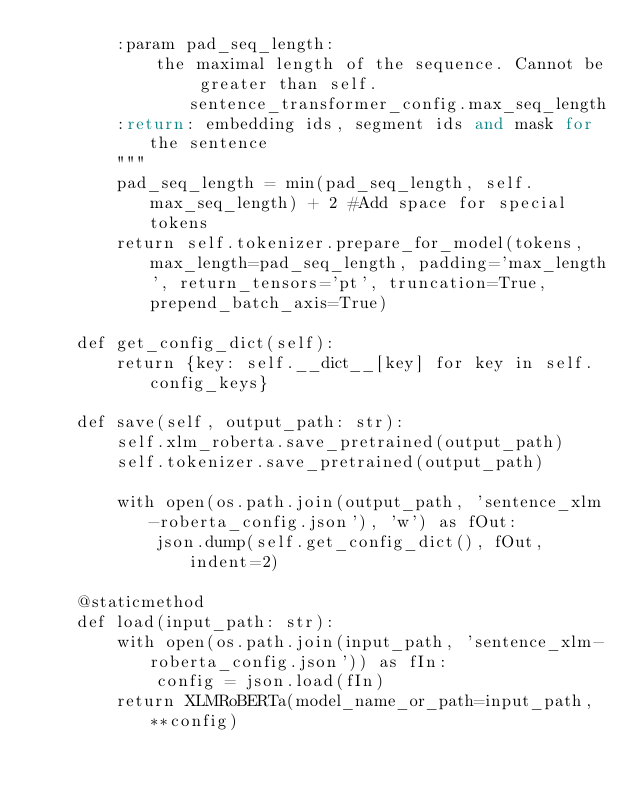<code> <loc_0><loc_0><loc_500><loc_500><_Python_>        :param pad_seq_length:
            the maximal length of the sequence. Cannot be greater than self.sentence_transformer_config.max_seq_length
        :return: embedding ids, segment ids and mask for the sentence
        """
        pad_seq_length = min(pad_seq_length, self.max_seq_length) + 2 #Add space for special tokens
        return self.tokenizer.prepare_for_model(tokens, max_length=pad_seq_length, padding='max_length', return_tensors='pt', truncation=True, prepend_batch_axis=True)

    def get_config_dict(self):
        return {key: self.__dict__[key] for key in self.config_keys}

    def save(self, output_path: str):
        self.xlm_roberta.save_pretrained(output_path)
        self.tokenizer.save_pretrained(output_path)

        with open(os.path.join(output_path, 'sentence_xlm-roberta_config.json'), 'w') as fOut:
            json.dump(self.get_config_dict(), fOut, indent=2)

    @staticmethod
    def load(input_path: str):
        with open(os.path.join(input_path, 'sentence_xlm-roberta_config.json')) as fIn:
            config = json.load(fIn)
        return XLMRoBERTa(model_name_or_path=input_path, **config)






</code> 